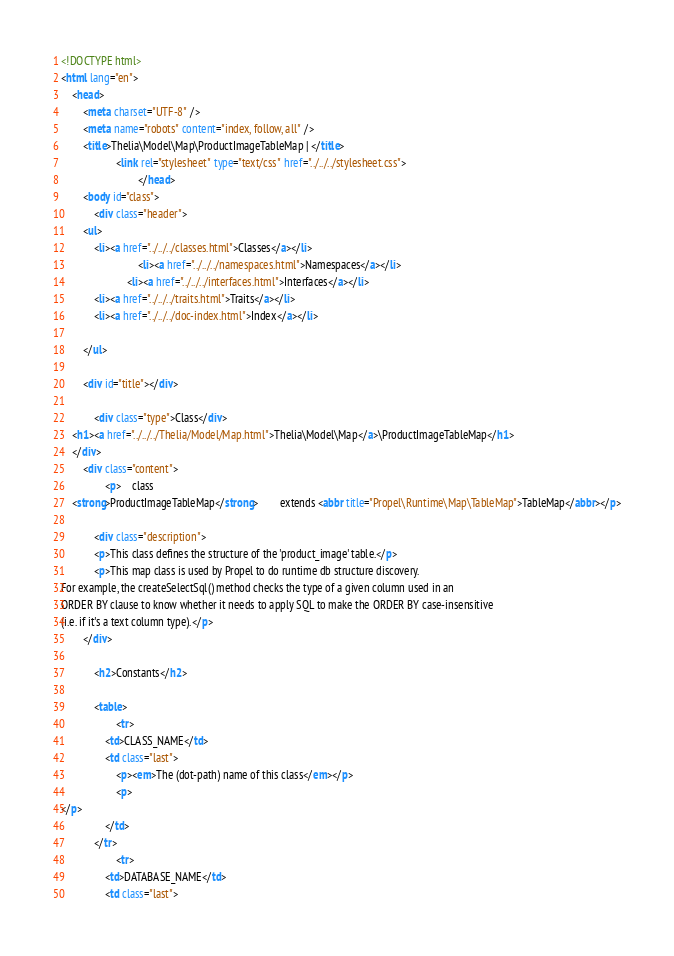<code> <loc_0><loc_0><loc_500><loc_500><_HTML_><!DOCTYPE html>
<html lang="en">
    <head>
        <meta charset="UTF-8" />
        <meta name="robots" content="index, follow, all" />
        <title>Thelia\Model\Map\ProductImageTableMap | </title>
                    <link rel="stylesheet" type="text/css" href="../../../stylesheet.css">
                            </head>
        <body id="class">
            <div class="header">
        <ul>
            <li><a href="../../../classes.html">Classes</a></li>
                            <li><a href="../../../namespaces.html">Namespaces</a></li>
                        <li><a href="../../../interfaces.html">Interfaces</a></li>
            <li><a href="../../../traits.html">Traits</a></li>
            <li><a href="../../../doc-index.html">Index</a></li>
            
        </ul>

        <div id="title"></div>

            <div class="type">Class</div>
    <h1><a href="../../../Thelia/Model/Map.html">Thelia\Model\Map</a>\ProductImageTableMap</h1>
    </div>
        <div class="content">
                <p>    class
    <strong>ProductImageTableMap</strong>        extends <abbr title="Propel\Runtime\Map\TableMap">TableMap</abbr></p>

            <div class="description">
            <p>This class defines the structure of the 'product_image' table.</p>
            <p>This map class is used by Propel to do runtime db structure discovery.
For example, the createSelectSql() method checks the type of a given column used in an
ORDER BY clause to know whether it needs to apply SQL to make the ORDER BY case-insensitive
(i.e. if it's a text column type).</p>
        </div>
    
            <h2>Constants</h2>

            <table>
                    <tr>
                <td>CLASS_NAME</td>
                <td class="last">
                    <p><em>The (dot-path) name of this class</em></p>
                    <p>
</p>
                </td>
            </tr>
                    <tr>
                <td>DATABASE_NAME</td>
                <td class="last"></code> 